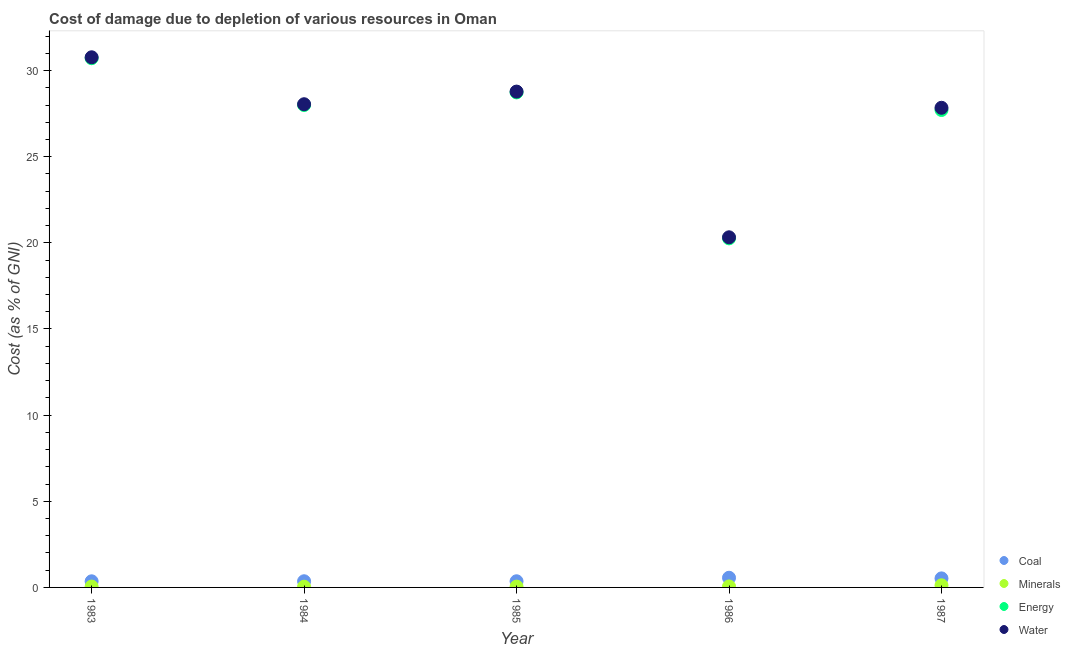How many different coloured dotlines are there?
Provide a succinct answer. 4. What is the cost of damage due to depletion of energy in 1985?
Provide a short and direct response. 28.73. Across all years, what is the maximum cost of damage due to depletion of energy?
Your response must be concise. 30.72. Across all years, what is the minimum cost of damage due to depletion of minerals?
Your answer should be very brief. 0.04. In which year was the cost of damage due to depletion of minerals maximum?
Ensure brevity in your answer.  1987. In which year was the cost of damage due to depletion of coal minimum?
Provide a short and direct response. 1983. What is the total cost of damage due to depletion of energy in the graph?
Your answer should be compact. 135.42. What is the difference between the cost of damage due to depletion of energy in 1985 and that in 1986?
Offer a very short reply. 8.47. What is the difference between the cost of damage due to depletion of minerals in 1985 and the cost of damage due to depletion of water in 1986?
Ensure brevity in your answer.  -20.28. What is the average cost of damage due to depletion of coal per year?
Your answer should be very brief. 0.43. In the year 1987, what is the difference between the cost of damage due to depletion of energy and cost of damage due to depletion of coal?
Offer a terse response. 27.19. What is the ratio of the cost of damage due to depletion of coal in 1983 to that in 1984?
Offer a very short reply. 0.99. What is the difference between the highest and the second highest cost of damage due to depletion of water?
Provide a succinct answer. 1.99. What is the difference between the highest and the lowest cost of damage due to depletion of minerals?
Your answer should be very brief. 0.08. In how many years, is the cost of damage due to depletion of water greater than the average cost of damage due to depletion of water taken over all years?
Your response must be concise. 4. Is it the case that in every year, the sum of the cost of damage due to depletion of water and cost of damage due to depletion of energy is greater than the sum of cost of damage due to depletion of minerals and cost of damage due to depletion of coal?
Your answer should be compact. Yes. Is it the case that in every year, the sum of the cost of damage due to depletion of coal and cost of damage due to depletion of minerals is greater than the cost of damage due to depletion of energy?
Your answer should be very brief. No. Does the cost of damage due to depletion of water monotonically increase over the years?
Keep it short and to the point. No. How many dotlines are there?
Offer a very short reply. 4. How many years are there in the graph?
Your response must be concise. 5. Are the values on the major ticks of Y-axis written in scientific E-notation?
Offer a terse response. No. Does the graph contain any zero values?
Offer a terse response. No. Where does the legend appear in the graph?
Make the answer very short. Bottom right. What is the title of the graph?
Offer a very short reply. Cost of damage due to depletion of various resources in Oman . What is the label or title of the X-axis?
Provide a succinct answer. Year. What is the label or title of the Y-axis?
Provide a short and direct response. Cost (as % of GNI). What is the Cost (as % of GNI) of Coal in 1983?
Make the answer very short. 0.36. What is the Cost (as % of GNI) of Minerals in 1983?
Offer a terse response. 0.05. What is the Cost (as % of GNI) of Energy in 1983?
Provide a succinct answer. 30.72. What is the Cost (as % of GNI) in Water in 1983?
Offer a terse response. 30.77. What is the Cost (as % of GNI) of Coal in 1984?
Offer a very short reply. 0.36. What is the Cost (as % of GNI) of Minerals in 1984?
Give a very brief answer. 0.04. What is the Cost (as % of GNI) of Energy in 1984?
Offer a terse response. 28. What is the Cost (as % of GNI) in Water in 1984?
Provide a short and direct response. 28.05. What is the Cost (as % of GNI) in Coal in 1985?
Provide a succinct answer. 0.36. What is the Cost (as % of GNI) in Minerals in 1985?
Your response must be concise. 0.05. What is the Cost (as % of GNI) of Energy in 1985?
Your answer should be very brief. 28.73. What is the Cost (as % of GNI) of Water in 1985?
Provide a succinct answer. 28.78. What is the Cost (as % of GNI) in Coal in 1986?
Offer a very short reply. 0.56. What is the Cost (as % of GNI) in Minerals in 1986?
Give a very brief answer. 0.06. What is the Cost (as % of GNI) of Energy in 1986?
Keep it short and to the point. 20.26. What is the Cost (as % of GNI) of Water in 1986?
Keep it short and to the point. 20.32. What is the Cost (as % of GNI) of Coal in 1987?
Your response must be concise. 0.52. What is the Cost (as % of GNI) of Minerals in 1987?
Give a very brief answer. 0.12. What is the Cost (as % of GNI) of Energy in 1987?
Give a very brief answer. 27.71. What is the Cost (as % of GNI) in Water in 1987?
Your answer should be compact. 27.84. Across all years, what is the maximum Cost (as % of GNI) in Coal?
Provide a short and direct response. 0.56. Across all years, what is the maximum Cost (as % of GNI) of Minerals?
Your response must be concise. 0.12. Across all years, what is the maximum Cost (as % of GNI) in Energy?
Keep it short and to the point. 30.72. Across all years, what is the maximum Cost (as % of GNI) of Water?
Offer a very short reply. 30.77. Across all years, what is the minimum Cost (as % of GNI) of Coal?
Offer a terse response. 0.36. Across all years, what is the minimum Cost (as % of GNI) in Minerals?
Your answer should be compact. 0.04. Across all years, what is the minimum Cost (as % of GNI) in Energy?
Offer a terse response. 20.26. Across all years, what is the minimum Cost (as % of GNI) in Water?
Make the answer very short. 20.32. What is the total Cost (as % of GNI) of Coal in the graph?
Provide a succinct answer. 2.16. What is the total Cost (as % of GNI) of Minerals in the graph?
Give a very brief answer. 0.32. What is the total Cost (as % of GNI) of Energy in the graph?
Your answer should be compact. 135.42. What is the total Cost (as % of GNI) in Water in the graph?
Offer a very short reply. 135.76. What is the difference between the Cost (as % of GNI) of Coal in 1983 and that in 1984?
Offer a terse response. -0. What is the difference between the Cost (as % of GNI) in Minerals in 1983 and that in 1984?
Provide a succinct answer. 0.01. What is the difference between the Cost (as % of GNI) of Energy in 1983 and that in 1984?
Give a very brief answer. 2.72. What is the difference between the Cost (as % of GNI) of Water in 1983 and that in 1984?
Your answer should be compact. 2.72. What is the difference between the Cost (as % of GNI) in Coal in 1983 and that in 1985?
Make the answer very short. -0. What is the difference between the Cost (as % of GNI) in Minerals in 1983 and that in 1985?
Keep it short and to the point. 0. What is the difference between the Cost (as % of GNI) of Energy in 1983 and that in 1985?
Offer a very short reply. 1.99. What is the difference between the Cost (as % of GNI) in Water in 1983 and that in 1985?
Provide a succinct answer. 1.99. What is the difference between the Cost (as % of GNI) of Coal in 1983 and that in 1986?
Give a very brief answer. -0.21. What is the difference between the Cost (as % of GNI) in Minerals in 1983 and that in 1986?
Give a very brief answer. -0.01. What is the difference between the Cost (as % of GNI) of Energy in 1983 and that in 1986?
Your answer should be very brief. 10.46. What is the difference between the Cost (as % of GNI) of Water in 1983 and that in 1986?
Make the answer very short. 10.45. What is the difference between the Cost (as % of GNI) in Coal in 1983 and that in 1987?
Ensure brevity in your answer.  -0.17. What is the difference between the Cost (as % of GNI) in Minerals in 1983 and that in 1987?
Your answer should be very brief. -0.07. What is the difference between the Cost (as % of GNI) in Energy in 1983 and that in 1987?
Keep it short and to the point. 3.01. What is the difference between the Cost (as % of GNI) of Water in 1983 and that in 1987?
Your answer should be very brief. 2.93. What is the difference between the Cost (as % of GNI) in Coal in 1984 and that in 1985?
Ensure brevity in your answer.  0. What is the difference between the Cost (as % of GNI) in Minerals in 1984 and that in 1985?
Offer a terse response. -0. What is the difference between the Cost (as % of GNI) in Energy in 1984 and that in 1985?
Give a very brief answer. -0.73. What is the difference between the Cost (as % of GNI) in Water in 1984 and that in 1985?
Give a very brief answer. -0.73. What is the difference between the Cost (as % of GNI) in Coal in 1984 and that in 1986?
Offer a very short reply. -0.2. What is the difference between the Cost (as % of GNI) of Minerals in 1984 and that in 1986?
Provide a succinct answer. -0.01. What is the difference between the Cost (as % of GNI) in Energy in 1984 and that in 1986?
Give a very brief answer. 7.74. What is the difference between the Cost (as % of GNI) of Water in 1984 and that in 1986?
Your response must be concise. 7.72. What is the difference between the Cost (as % of GNI) in Coal in 1984 and that in 1987?
Your response must be concise. -0.17. What is the difference between the Cost (as % of GNI) in Minerals in 1984 and that in 1987?
Provide a succinct answer. -0.08. What is the difference between the Cost (as % of GNI) of Energy in 1984 and that in 1987?
Your answer should be very brief. 0.29. What is the difference between the Cost (as % of GNI) in Water in 1984 and that in 1987?
Your answer should be very brief. 0.21. What is the difference between the Cost (as % of GNI) in Coal in 1985 and that in 1986?
Make the answer very short. -0.2. What is the difference between the Cost (as % of GNI) of Minerals in 1985 and that in 1986?
Give a very brief answer. -0.01. What is the difference between the Cost (as % of GNI) of Energy in 1985 and that in 1986?
Your answer should be very brief. 8.47. What is the difference between the Cost (as % of GNI) of Water in 1985 and that in 1986?
Provide a short and direct response. 8.46. What is the difference between the Cost (as % of GNI) in Coal in 1985 and that in 1987?
Make the answer very short. -0.17. What is the difference between the Cost (as % of GNI) in Minerals in 1985 and that in 1987?
Your answer should be very brief. -0.08. What is the difference between the Cost (as % of GNI) of Energy in 1985 and that in 1987?
Make the answer very short. 1.02. What is the difference between the Cost (as % of GNI) in Water in 1985 and that in 1987?
Offer a terse response. 0.94. What is the difference between the Cost (as % of GNI) in Coal in 1986 and that in 1987?
Offer a very short reply. 0.04. What is the difference between the Cost (as % of GNI) in Minerals in 1986 and that in 1987?
Your answer should be compact. -0.07. What is the difference between the Cost (as % of GNI) of Energy in 1986 and that in 1987?
Provide a short and direct response. -7.45. What is the difference between the Cost (as % of GNI) of Water in 1986 and that in 1987?
Provide a succinct answer. -7.52. What is the difference between the Cost (as % of GNI) of Coal in 1983 and the Cost (as % of GNI) of Minerals in 1984?
Provide a succinct answer. 0.31. What is the difference between the Cost (as % of GNI) in Coal in 1983 and the Cost (as % of GNI) in Energy in 1984?
Provide a succinct answer. -27.64. What is the difference between the Cost (as % of GNI) of Coal in 1983 and the Cost (as % of GNI) of Water in 1984?
Your answer should be compact. -27.69. What is the difference between the Cost (as % of GNI) in Minerals in 1983 and the Cost (as % of GNI) in Energy in 1984?
Offer a very short reply. -27.95. What is the difference between the Cost (as % of GNI) of Minerals in 1983 and the Cost (as % of GNI) of Water in 1984?
Your response must be concise. -28. What is the difference between the Cost (as % of GNI) of Energy in 1983 and the Cost (as % of GNI) of Water in 1984?
Provide a short and direct response. 2.67. What is the difference between the Cost (as % of GNI) of Coal in 1983 and the Cost (as % of GNI) of Minerals in 1985?
Keep it short and to the point. 0.31. What is the difference between the Cost (as % of GNI) of Coal in 1983 and the Cost (as % of GNI) of Energy in 1985?
Provide a short and direct response. -28.38. What is the difference between the Cost (as % of GNI) of Coal in 1983 and the Cost (as % of GNI) of Water in 1985?
Offer a very short reply. -28.42. What is the difference between the Cost (as % of GNI) in Minerals in 1983 and the Cost (as % of GNI) in Energy in 1985?
Offer a terse response. -28.68. What is the difference between the Cost (as % of GNI) of Minerals in 1983 and the Cost (as % of GNI) of Water in 1985?
Keep it short and to the point. -28.73. What is the difference between the Cost (as % of GNI) of Energy in 1983 and the Cost (as % of GNI) of Water in 1985?
Your answer should be compact. 1.94. What is the difference between the Cost (as % of GNI) of Coal in 1983 and the Cost (as % of GNI) of Minerals in 1986?
Your answer should be very brief. 0.3. What is the difference between the Cost (as % of GNI) of Coal in 1983 and the Cost (as % of GNI) of Energy in 1986?
Keep it short and to the point. -19.91. What is the difference between the Cost (as % of GNI) in Coal in 1983 and the Cost (as % of GNI) in Water in 1986?
Offer a very short reply. -19.97. What is the difference between the Cost (as % of GNI) of Minerals in 1983 and the Cost (as % of GNI) of Energy in 1986?
Your answer should be very brief. -20.21. What is the difference between the Cost (as % of GNI) of Minerals in 1983 and the Cost (as % of GNI) of Water in 1986?
Provide a succinct answer. -20.27. What is the difference between the Cost (as % of GNI) in Energy in 1983 and the Cost (as % of GNI) in Water in 1986?
Keep it short and to the point. 10.4. What is the difference between the Cost (as % of GNI) of Coal in 1983 and the Cost (as % of GNI) of Minerals in 1987?
Ensure brevity in your answer.  0.23. What is the difference between the Cost (as % of GNI) in Coal in 1983 and the Cost (as % of GNI) in Energy in 1987?
Offer a terse response. -27.36. What is the difference between the Cost (as % of GNI) of Coal in 1983 and the Cost (as % of GNI) of Water in 1987?
Offer a terse response. -27.48. What is the difference between the Cost (as % of GNI) in Minerals in 1983 and the Cost (as % of GNI) in Energy in 1987?
Your answer should be very brief. -27.66. What is the difference between the Cost (as % of GNI) in Minerals in 1983 and the Cost (as % of GNI) in Water in 1987?
Your answer should be compact. -27.79. What is the difference between the Cost (as % of GNI) of Energy in 1983 and the Cost (as % of GNI) of Water in 1987?
Keep it short and to the point. 2.88. What is the difference between the Cost (as % of GNI) of Coal in 1984 and the Cost (as % of GNI) of Minerals in 1985?
Your answer should be very brief. 0.31. What is the difference between the Cost (as % of GNI) in Coal in 1984 and the Cost (as % of GNI) in Energy in 1985?
Offer a terse response. -28.37. What is the difference between the Cost (as % of GNI) of Coal in 1984 and the Cost (as % of GNI) of Water in 1985?
Your answer should be very brief. -28.42. What is the difference between the Cost (as % of GNI) in Minerals in 1984 and the Cost (as % of GNI) in Energy in 1985?
Make the answer very short. -28.69. What is the difference between the Cost (as % of GNI) in Minerals in 1984 and the Cost (as % of GNI) in Water in 1985?
Offer a very short reply. -28.74. What is the difference between the Cost (as % of GNI) of Energy in 1984 and the Cost (as % of GNI) of Water in 1985?
Provide a succinct answer. -0.78. What is the difference between the Cost (as % of GNI) of Coal in 1984 and the Cost (as % of GNI) of Minerals in 1986?
Your answer should be very brief. 0.3. What is the difference between the Cost (as % of GNI) of Coal in 1984 and the Cost (as % of GNI) of Energy in 1986?
Keep it short and to the point. -19.9. What is the difference between the Cost (as % of GNI) of Coal in 1984 and the Cost (as % of GNI) of Water in 1986?
Provide a short and direct response. -19.96. What is the difference between the Cost (as % of GNI) of Minerals in 1984 and the Cost (as % of GNI) of Energy in 1986?
Offer a very short reply. -20.22. What is the difference between the Cost (as % of GNI) of Minerals in 1984 and the Cost (as % of GNI) of Water in 1986?
Provide a short and direct response. -20.28. What is the difference between the Cost (as % of GNI) of Energy in 1984 and the Cost (as % of GNI) of Water in 1986?
Your answer should be very brief. 7.68. What is the difference between the Cost (as % of GNI) in Coal in 1984 and the Cost (as % of GNI) in Minerals in 1987?
Give a very brief answer. 0.24. What is the difference between the Cost (as % of GNI) of Coal in 1984 and the Cost (as % of GNI) of Energy in 1987?
Provide a short and direct response. -27.35. What is the difference between the Cost (as % of GNI) in Coal in 1984 and the Cost (as % of GNI) in Water in 1987?
Provide a short and direct response. -27.48. What is the difference between the Cost (as % of GNI) of Minerals in 1984 and the Cost (as % of GNI) of Energy in 1987?
Your response must be concise. -27.67. What is the difference between the Cost (as % of GNI) of Minerals in 1984 and the Cost (as % of GNI) of Water in 1987?
Keep it short and to the point. -27.8. What is the difference between the Cost (as % of GNI) in Energy in 1984 and the Cost (as % of GNI) in Water in 1987?
Provide a short and direct response. 0.16. What is the difference between the Cost (as % of GNI) of Coal in 1985 and the Cost (as % of GNI) of Minerals in 1986?
Make the answer very short. 0.3. What is the difference between the Cost (as % of GNI) in Coal in 1985 and the Cost (as % of GNI) in Energy in 1986?
Ensure brevity in your answer.  -19.9. What is the difference between the Cost (as % of GNI) of Coal in 1985 and the Cost (as % of GNI) of Water in 1986?
Give a very brief answer. -19.96. What is the difference between the Cost (as % of GNI) in Minerals in 1985 and the Cost (as % of GNI) in Energy in 1986?
Your answer should be very brief. -20.21. What is the difference between the Cost (as % of GNI) in Minerals in 1985 and the Cost (as % of GNI) in Water in 1986?
Provide a succinct answer. -20.28. What is the difference between the Cost (as % of GNI) of Energy in 1985 and the Cost (as % of GNI) of Water in 1986?
Keep it short and to the point. 8.41. What is the difference between the Cost (as % of GNI) in Coal in 1985 and the Cost (as % of GNI) in Minerals in 1987?
Give a very brief answer. 0.23. What is the difference between the Cost (as % of GNI) in Coal in 1985 and the Cost (as % of GNI) in Energy in 1987?
Keep it short and to the point. -27.35. What is the difference between the Cost (as % of GNI) in Coal in 1985 and the Cost (as % of GNI) in Water in 1987?
Offer a very short reply. -27.48. What is the difference between the Cost (as % of GNI) of Minerals in 1985 and the Cost (as % of GNI) of Energy in 1987?
Keep it short and to the point. -27.67. What is the difference between the Cost (as % of GNI) in Minerals in 1985 and the Cost (as % of GNI) in Water in 1987?
Provide a succinct answer. -27.79. What is the difference between the Cost (as % of GNI) in Energy in 1985 and the Cost (as % of GNI) in Water in 1987?
Give a very brief answer. 0.89. What is the difference between the Cost (as % of GNI) of Coal in 1986 and the Cost (as % of GNI) of Minerals in 1987?
Provide a short and direct response. 0.44. What is the difference between the Cost (as % of GNI) in Coal in 1986 and the Cost (as % of GNI) in Energy in 1987?
Give a very brief answer. -27.15. What is the difference between the Cost (as % of GNI) in Coal in 1986 and the Cost (as % of GNI) in Water in 1987?
Your answer should be very brief. -27.28. What is the difference between the Cost (as % of GNI) in Minerals in 1986 and the Cost (as % of GNI) in Energy in 1987?
Your answer should be very brief. -27.65. What is the difference between the Cost (as % of GNI) in Minerals in 1986 and the Cost (as % of GNI) in Water in 1987?
Give a very brief answer. -27.78. What is the difference between the Cost (as % of GNI) in Energy in 1986 and the Cost (as % of GNI) in Water in 1987?
Provide a succinct answer. -7.58. What is the average Cost (as % of GNI) in Coal per year?
Make the answer very short. 0.43. What is the average Cost (as % of GNI) in Minerals per year?
Provide a succinct answer. 0.06. What is the average Cost (as % of GNI) of Energy per year?
Your response must be concise. 27.08. What is the average Cost (as % of GNI) in Water per year?
Your response must be concise. 27.15. In the year 1983, what is the difference between the Cost (as % of GNI) of Coal and Cost (as % of GNI) of Minerals?
Make the answer very short. 0.31. In the year 1983, what is the difference between the Cost (as % of GNI) of Coal and Cost (as % of GNI) of Energy?
Provide a short and direct response. -30.36. In the year 1983, what is the difference between the Cost (as % of GNI) of Coal and Cost (as % of GNI) of Water?
Make the answer very short. -30.41. In the year 1983, what is the difference between the Cost (as % of GNI) of Minerals and Cost (as % of GNI) of Energy?
Make the answer very short. -30.67. In the year 1983, what is the difference between the Cost (as % of GNI) in Minerals and Cost (as % of GNI) in Water?
Keep it short and to the point. -30.72. In the year 1983, what is the difference between the Cost (as % of GNI) in Energy and Cost (as % of GNI) in Water?
Provide a short and direct response. -0.05. In the year 1984, what is the difference between the Cost (as % of GNI) of Coal and Cost (as % of GNI) of Minerals?
Keep it short and to the point. 0.32. In the year 1984, what is the difference between the Cost (as % of GNI) of Coal and Cost (as % of GNI) of Energy?
Provide a short and direct response. -27.64. In the year 1984, what is the difference between the Cost (as % of GNI) of Coal and Cost (as % of GNI) of Water?
Offer a terse response. -27.69. In the year 1984, what is the difference between the Cost (as % of GNI) in Minerals and Cost (as % of GNI) in Energy?
Ensure brevity in your answer.  -27.96. In the year 1984, what is the difference between the Cost (as % of GNI) in Minerals and Cost (as % of GNI) in Water?
Your answer should be compact. -28. In the year 1984, what is the difference between the Cost (as % of GNI) in Energy and Cost (as % of GNI) in Water?
Make the answer very short. -0.05. In the year 1985, what is the difference between the Cost (as % of GNI) of Coal and Cost (as % of GNI) of Minerals?
Make the answer very short. 0.31. In the year 1985, what is the difference between the Cost (as % of GNI) of Coal and Cost (as % of GNI) of Energy?
Your answer should be very brief. -28.37. In the year 1985, what is the difference between the Cost (as % of GNI) of Coal and Cost (as % of GNI) of Water?
Your answer should be very brief. -28.42. In the year 1985, what is the difference between the Cost (as % of GNI) in Minerals and Cost (as % of GNI) in Energy?
Keep it short and to the point. -28.69. In the year 1985, what is the difference between the Cost (as % of GNI) in Minerals and Cost (as % of GNI) in Water?
Ensure brevity in your answer.  -28.73. In the year 1985, what is the difference between the Cost (as % of GNI) in Energy and Cost (as % of GNI) in Water?
Your response must be concise. -0.05. In the year 1986, what is the difference between the Cost (as % of GNI) of Coal and Cost (as % of GNI) of Minerals?
Your answer should be very brief. 0.5. In the year 1986, what is the difference between the Cost (as % of GNI) in Coal and Cost (as % of GNI) in Energy?
Your response must be concise. -19.7. In the year 1986, what is the difference between the Cost (as % of GNI) in Coal and Cost (as % of GNI) in Water?
Provide a succinct answer. -19.76. In the year 1986, what is the difference between the Cost (as % of GNI) of Minerals and Cost (as % of GNI) of Energy?
Provide a short and direct response. -20.2. In the year 1986, what is the difference between the Cost (as % of GNI) in Minerals and Cost (as % of GNI) in Water?
Keep it short and to the point. -20.27. In the year 1986, what is the difference between the Cost (as % of GNI) of Energy and Cost (as % of GNI) of Water?
Your answer should be very brief. -0.06. In the year 1987, what is the difference between the Cost (as % of GNI) of Coal and Cost (as % of GNI) of Minerals?
Your answer should be compact. 0.4. In the year 1987, what is the difference between the Cost (as % of GNI) in Coal and Cost (as % of GNI) in Energy?
Your answer should be very brief. -27.19. In the year 1987, what is the difference between the Cost (as % of GNI) of Coal and Cost (as % of GNI) of Water?
Your response must be concise. -27.32. In the year 1987, what is the difference between the Cost (as % of GNI) in Minerals and Cost (as % of GNI) in Energy?
Your answer should be compact. -27.59. In the year 1987, what is the difference between the Cost (as % of GNI) in Minerals and Cost (as % of GNI) in Water?
Offer a very short reply. -27.72. In the year 1987, what is the difference between the Cost (as % of GNI) of Energy and Cost (as % of GNI) of Water?
Offer a very short reply. -0.13. What is the ratio of the Cost (as % of GNI) of Coal in 1983 to that in 1984?
Provide a short and direct response. 0.99. What is the ratio of the Cost (as % of GNI) in Minerals in 1983 to that in 1984?
Provide a short and direct response. 1.15. What is the ratio of the Cost (as % of GNI) of Energy in 1983 to that in 1984?
Make the answer very short. 1.1. What is the ratio of the Cost (as % of GNI) in Water in 1983 to that in 1984?
Your answer should be compact. 1.1. What is the ratio of the Cost (as % of GNI) of Coal in 1983 to that in 1985?
Provide a short and direct response. 0.99. What is the ratio of the Cost (as % of GNI) of Minerals in 1983 to that in 1985?
Your answer should be compact. 1.06. What is the ratio of the Cost (as % of GNI) in Energy in 1983 to that in 1985?
Keep it short and to the point. 1.07. What is the ratio of the Cost (as % of GNI) in Water in 1983 to that in 1985?
Offer a terse response. 1.07. What is the ratio of the Cost (as % of GNI) in Coal in 1983 to that in 1986?
Keep it short and to the point. 0.63. What is the ratio of the Cost (as % of GNI) in Minerals in 1983 to that in 1986?
Provide a short and direct response. 0.85. What is the ratio of the Cost (as % of GNI) of Energy in 1983 to that in 1986?
Offer a very short reply. 1.52. What is the ratio of the Cost (as % of GNI) of Water in 1983 to that in 1986?
Provide a succinct answer. 1.51. What is the ratio of the Cost (as % of GNI) in Coal in 1983 to that in 1987?
Make the answer very short. 0.68. What is the ratio of the Cost (as % of GNI) of Minerals in 1983 to that in 1987?
Offer a very short reply. 0.4. What is the ratio of the Cost (as % of GNI) in Energy in 1983 to that in 1987?
Provide a succinct answer. 1.11. What is the ratio of the Cost (as % of GNI) in Water in 1983 to that in 1987?
Your answer should be compact. 1.11. What is the ratio of the Cost (as % of GNI) of Minerals in 1984 to that in 1985?
Provide a succinct answer. 0.92. What is the ratio of the Cost (as % of GNI) of Energy in 1984 to that in 1985?
Provide a succinct answer. 0.97. What is the ratio of the Cost (as % of GNI) in Water in 1984 to that in 1985?
Your response must be concise. 0.97. What is the ratio of the Cost (as % of GNI) in Coal in 1984 to that in 1986?
Offer a terse response. 0.64. What is the ratio of the Cost (as % of GNI) of Minerals in 1984 to that in 1986?
Provide a succinct answer. 0.74. What is the ratio of the Cost (as % of GNI) in Energy in 1984 to that in 1986?
Ensure brevity in your answer.  1.38. What is the ratio of the Cost (as % of GNI) of Water in 1984 to that in 1986?
Offer a very short reply. 1.38. What is the ratio of the Cost (as % of GNI) of Coal in 1984 to that in 1987?
Ensure brevity in your answer.  0.68. What is the ratio of the Cost (as % of GNI) of Minerals in 1984 to that in 1987?
Your answer should be very brief. 0.34. What is the ratio of the Cost (as % of GNI) in Energy in 1984 to that in 1987?
Ensure brevity in your answer.  1.01. What is the ratio of the Cost (as % of GNI) of Water in 1984 to that in 1987?
Your answer should be compact. 1.01. What is the ratio of the Cost (as % of GNI) in Coal in 1985 to that in 1986?
Offer a very short reply. 0.64. What is the ratio of the Cost (as % of GNI) in Minerals in 1985 to that in 1986?
Offer a very short reply. 0.8. What is the ratio of the Cost (as % of GNI) of Energy in 1985 to that in 1986?
Provide a short and direct response. 1.42. What is the ratio of the Cost (as % of GNI) in Water in 1985 to that in 1986?
Your answer should be very brief. 1.42. What is the ratio of the Cost (as % of GNI) in Coal in 1985 to that in 1987?
Offer a very short reply. 0.68. What is the ratio of the Cost (as % of GNI) of Minerals in 1985 to that in 1987?
Your answer should be compact. 0.38. What is the ratio of the Cost (as % of GNI) in Energy in 1985 to that in 1987?
Your response must be concise. 1.04. What is the ratio of the Cost (as % of GNI) in Water in 1985 to that in 1987?
Keep it short and to the point. 1.03. What is the ratio of the Cost (as % of GNI) of Coal in 1986 to that in 1987?
Keep it short and to the point. 1.07. What is the ratio of the Cost (as % of GNI) in Minerals in 1986 to that in 1987?
Make the answer very short. 0.47. What is the ratio of the Cost (as % of GNI) in Energy in 1986 to that in 1987?
Offer a very short reply. 0.73. What is the ratio of the Cost (as % of GNI) in Water in 1986 to that in 1987?
Offer a terse response. 0.73. What is the difference between the highest and the second highest Cost (as % of GNI) of Coal?
Provide a succinct answer. 0.04. What is the difference between the highest and the second highest Cost (as % of GNI) in Minerals?
Offer a very short reply. 0.07. What is the difference between the highest and the second highest Cost (as % of GNI) in Energy?
Offer a terse response. 1.99. What is the difference between the highest and the second highest Cost (as % of GNI) of Water?
Ensure brevity in your answer.  1.99. What is the difference between the highest and the lowest Cost (as % of GNI) in Coal?
Your answer should be very brief. 0.21. What is the difference between the highest and the lowest Cost (as % of GNI) of Minerals?
Give a very brief answer. 0.08. What is the difference between the highest and the lowest Cost (as % of GNI) of Energy?
Your answer should be very brief. 10.46. What is the difference between the highest and the lowest Cost (as % of GNI) of Water?
Your response must be concise. 10.45. 